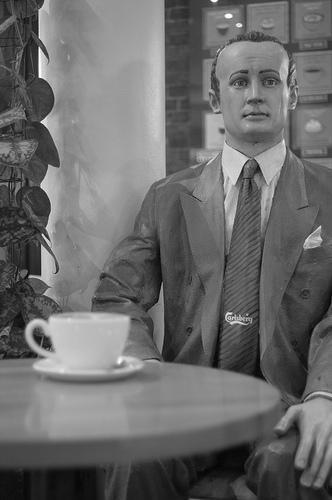How many tables are there?
Give a very brief answer. 1. 